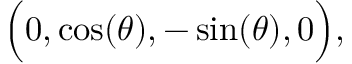<formula> <loc_0><loc_0><loc_500><loc_500>{ \left ( } 0 , \cos ( \theta ) , - \sin ( \theta ) , 0 { \right ) } ,</formula> 